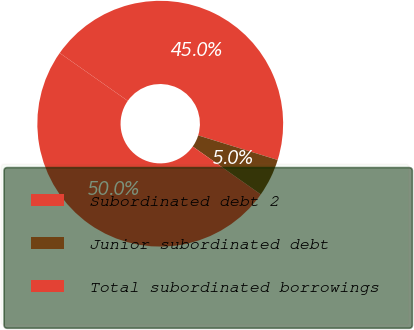Convert chart to OTSL. <chart><loc_0><loc_0><loc_500><loc_500><pie_chart><fcel>Subordinated debt 2<fcel>Junior subordinated debt<fcel>Total subordinated borrowings<nl><fcel>45.01%<fcel>4.99%<fcel>50.0%<nl></chart> 